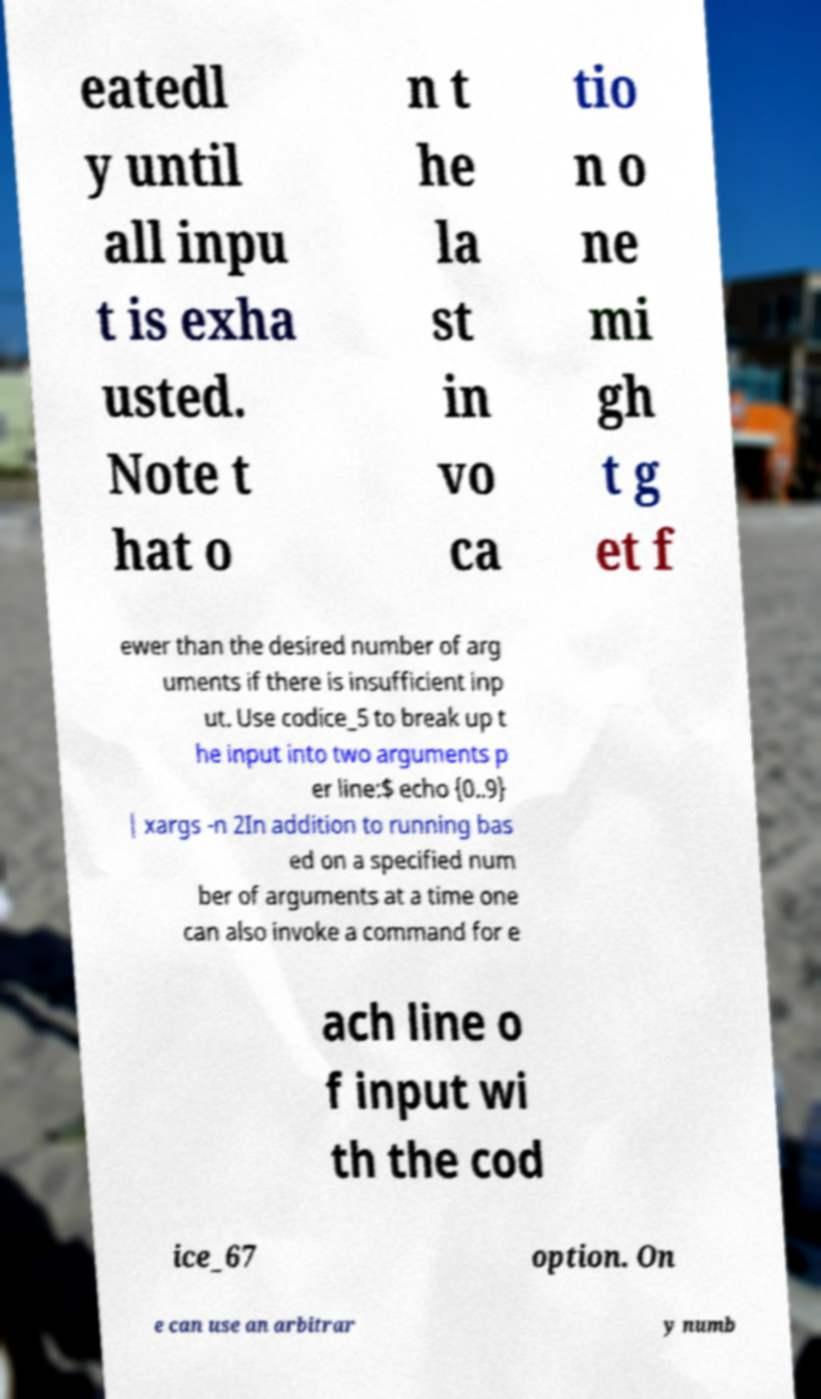Could you assist in decoding the text presented in this image and type it out clearly? eatedl y until all inpu t is exha usted. Note t hat o n t he la st in vo ca tio n o ne mi gh t g et f ewer than the desired number of arg uments if there is insufficient inp ut. Use codice_5 to break up t he input into two arguments p er line:$ echo {0..9} | xargs -n 2In addition to running bas ed on a specified num ber of arguments at a time one can also invoke a command for e ach line o f input wi th the cod ice_67 option. On e can use an arbitrar y numb 